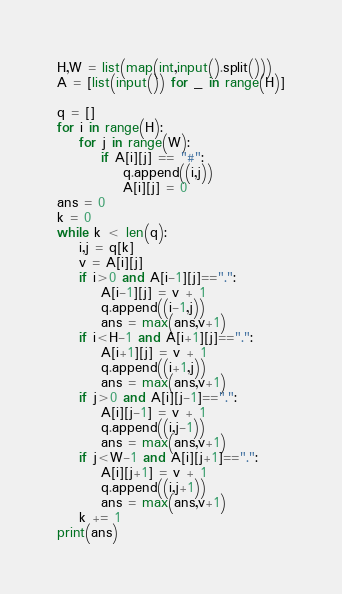<code> <loc_0><loc_0><loc_500><loc_500><_Python_>H,W = list(map(int,input().split()))
A = [list(input()) for _ in range(H)]

q = []
for i in range(H):
    for j in range(W):
        if A[i][j] == "#":
            q.append((i,j))
            A[i][j] = 0
ans = 0
k = 0
while k < len(q):
    i,j = q[k]
    v = A[i][j]
    if i>0 and A[i-1][j]==".":
        A[i-1][j] = v + 1
        q.append((i-1,j))
        ans = max(ans,v+1)
    if i<H-1 and A[i+1][j]==".":
        A[i+1][j] = v + 1
        q.append((i+1,j))
        ans = max(ans,v+1)
    if j>0 and A[i][j-1]==".":
        A[i][j-1] = v + 1
        q.append((i,j-1))
        ans = max(ans,v+1)
    if j<W-1 and A[i][j+1]==".":
        A[i][j+1] = v + 1
        q.append((i,j+1))
        ans = max(ans,v+1)
    k += 1
print(ans)</code> 